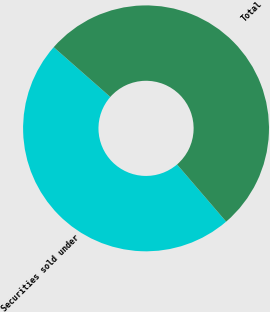Convert chart to OTSL. <chart><loc_0><loc_0><loc_500><loc_500><pie_chart><fcel>Securities sold under<fcel>Total<nl><fcel>47.77%<fcel>52.23%<nl></chart> 